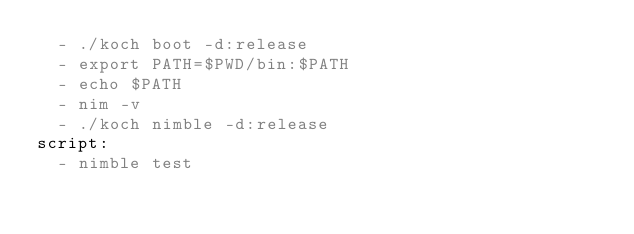<code> <loc_0><loc_0><loc_500><loc_500><_YAML_>  - ./koch boot -d:release
  - export PATH=$PWD/bin:$PATH
  - echo $PATH
  - nim -v
  - ./koch nimble -d:release
script:
  - nimble test
</code> 